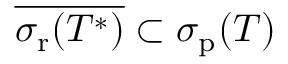Convert formula to latex. <formula><loc_0><loc_0><loc_500><loc_500>{ \overline { { \sigma _ { r } ( T ^ { * } ) } } } \subset \sigma _ { p } ( T )</formula> 